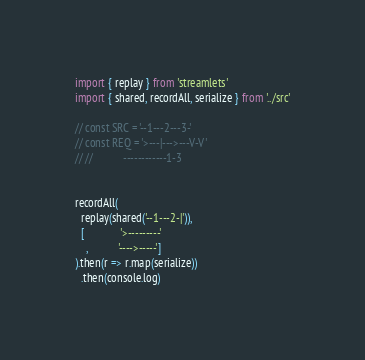Convert code to text. <code><loc_0><loc_0><loc_500><loc_500><_TypeScript_>import { replay } from 'streamlets'
import { shared, recordAll, serialize } from '../src'

// const SRC = '--1---2---3-'
// const REQ = '>---|--->---V-V'
// //           ------------1-3


recordAll(
  replay(shared('--1---2-|')),
  [             '>---------'
    ,           '---->-----']
).then(r => r.map(serialize))
  .then(console.log)

</code> 